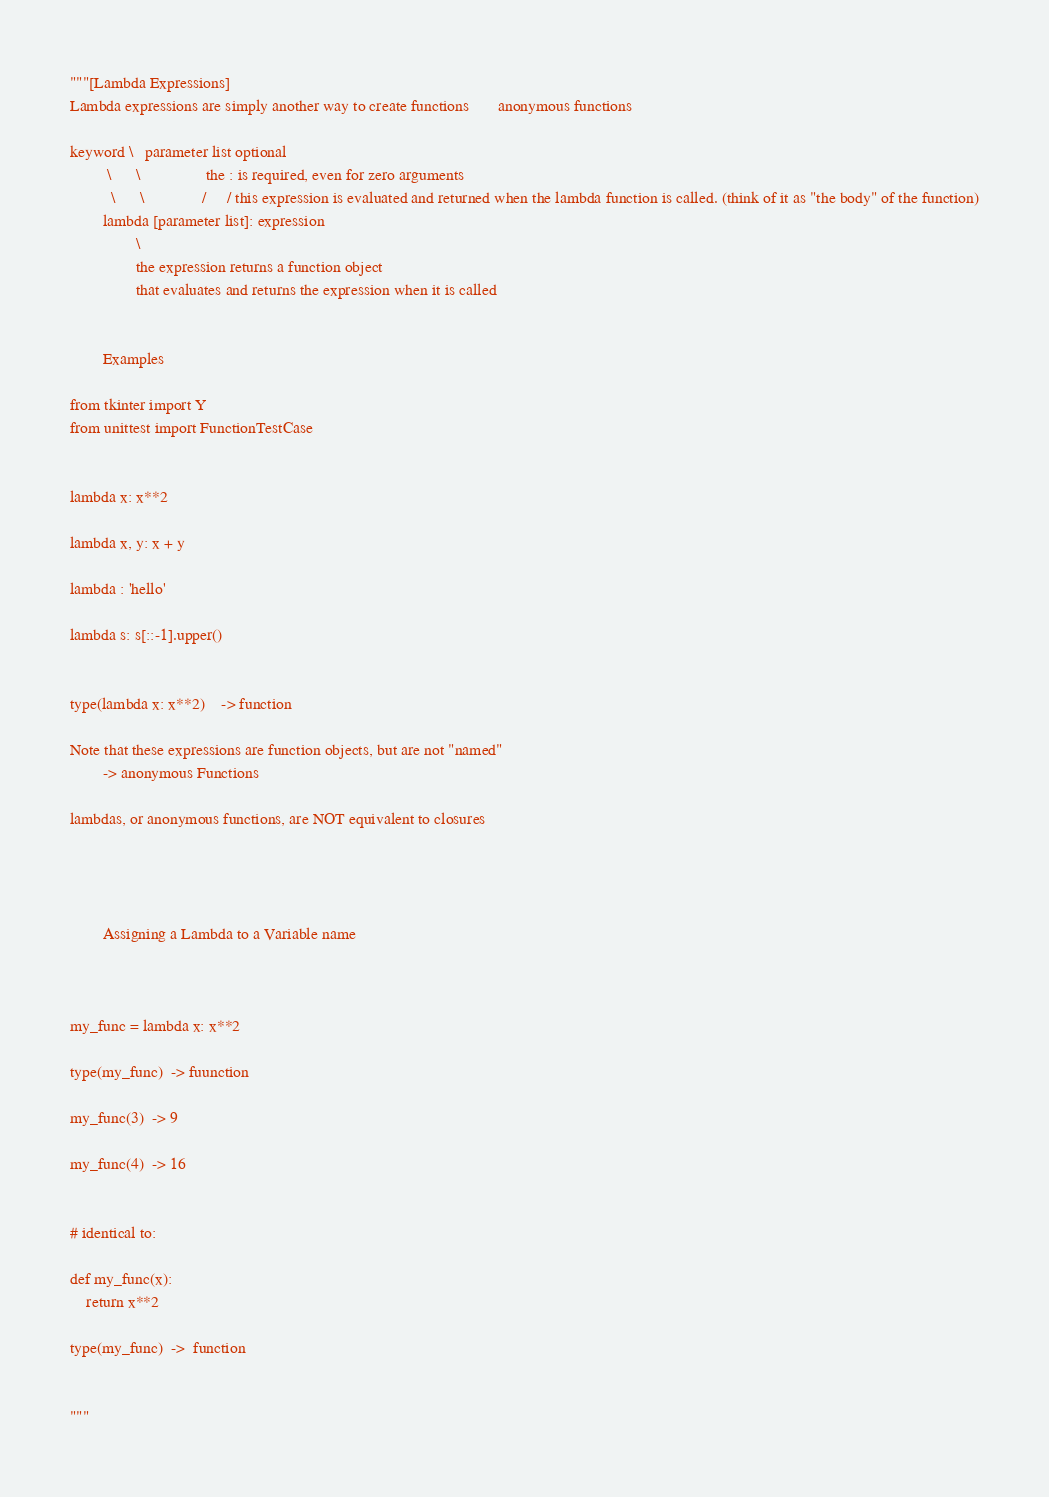Convert code to text. <code><loc_0><loc_0><loc_500><loc_500><_Python_>"""[Lambda Expressions]
Lambda expressions are simply another way to create functions       anonymous functions

keyword \   parameter list optional
         \      \                the : is required, even for zero arguments
          \      \              /     / this expression is evaluated and returned when the lambda function is called. (think of it as "the body" of the function)
        lambda [parameter list]: expression
                \
                the expression returns a function object
                that evaluates and returns the expression when it is called


        Examples

from tkinter import Y
from unittest import FunctionTestCase


lambda x: x**2

lambda x, y: x + y

lambda : 'hello'

lambda s: s[::-1].upper()


type(lambda x: x**2)    -> function

Note that these expressions are function objects, but are not "named"
        -> anonymous Functions

lambdas, or anonymous functions, are NOT equivalent to closures




        Assigning a Lambda to a Variable name



my_func = lambda x: x**2

type(my_func)  -> fuunction

my_func(3)  -> 9

my_func(4)  -> 16


# identical to:

def my_func(x):
    return x**2

type(my_func)  ->  function


"""</code> 